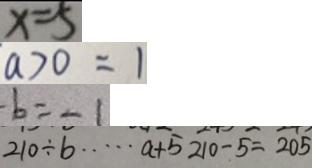Convert formula to latex. <formula><loc_0><loc_0><loc_500><loc_500>x = 5 
 a > 0 = 1 
 - b = - 1 
 2 1 0 \div b \cdots a + 5 2 1 0 - 5 = 2 0 5</formula> 